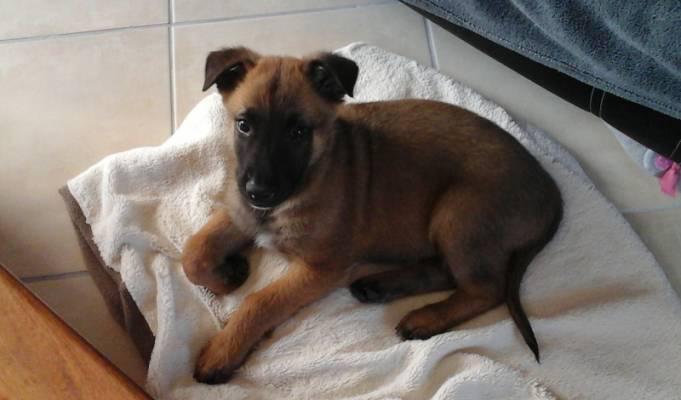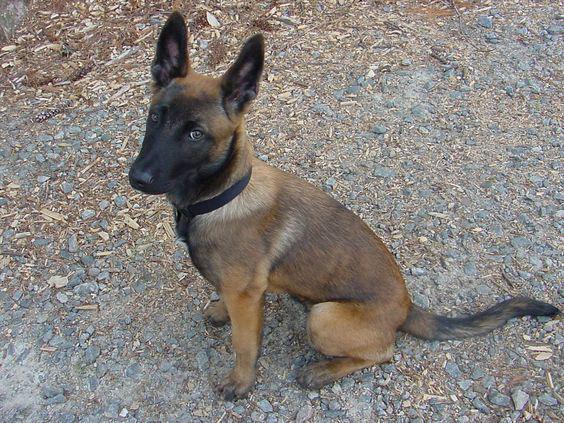The first image is the image on the left, the second image is the image on the right. Given the left and right images, does the statement "The dog in the right image is sitting upright, with head turned leftward." hold true? Answer yes or no. Yes. The first image is the image on the left, the second image is the image on the right. For the images displayed, is the sentence "None of the dogs has their mouths open." factually correct? Answer yes or no. Yes. 